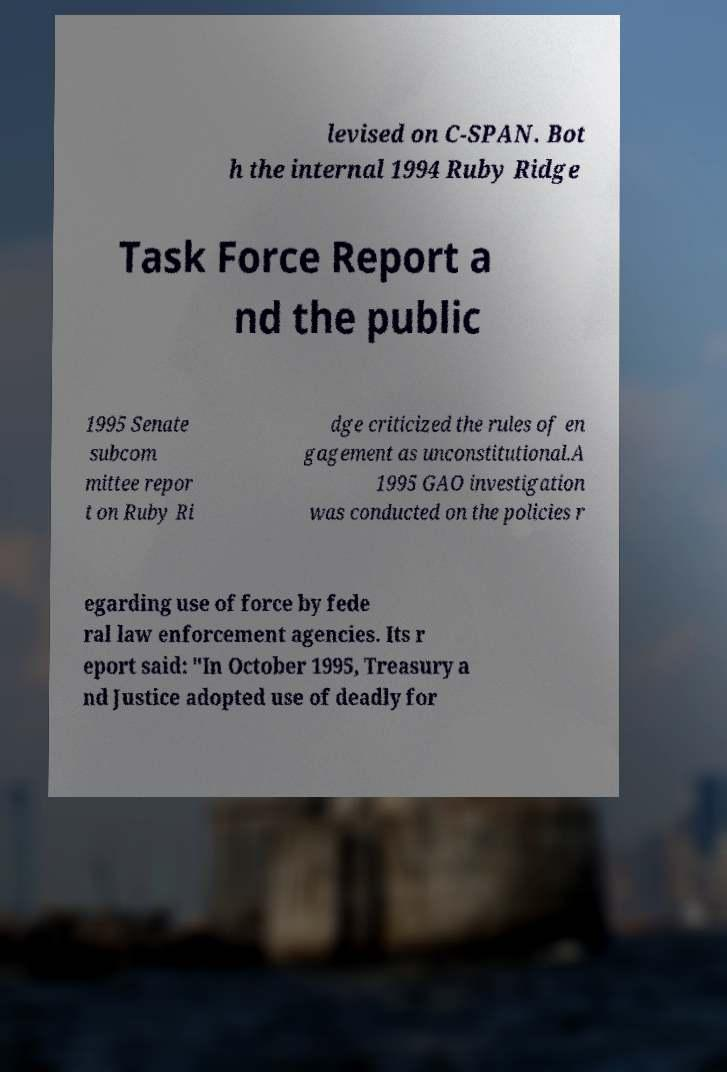What messages or text are displayed in this image? I need them in a readable, typed format. levised on C-SPAN. Bot h the internal 1994 Ruby Ridge Task Force Report a nd the public 1995 Senate subcom mittee repor t on Ruby Ri dge criticized the rules of en gagement as unconstitutional.A 1995 GAO investigation was conducted on the policies r egarding use of force by fede ral law enforcement agencies. Its r eport said: "In October 1995, Treasury a nd Justice adopted use of deadly for 